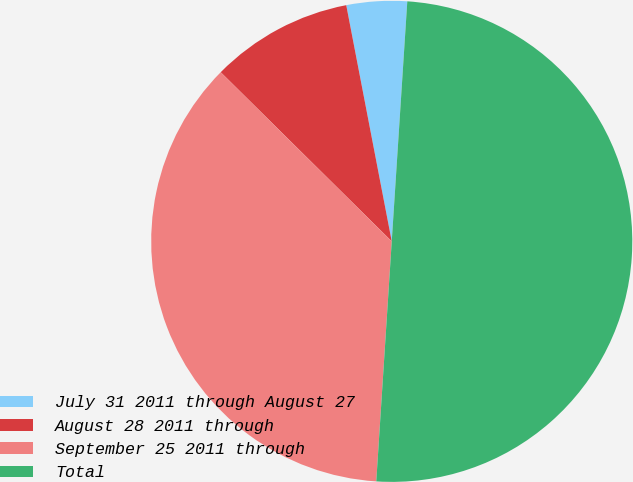Convert chart to OTSL. <chart><loc_0><loc_0><loc_500><loc_500><pie_chart><fcel>July 31 2011 through August 27<fcel>August 28 2011 through<fcel>September 25 2011 through<fcel>Total<nl><fcel>4.06%<fcel>9.56%<fcel>36.39%<fcel>50.0%<nl></chart> 